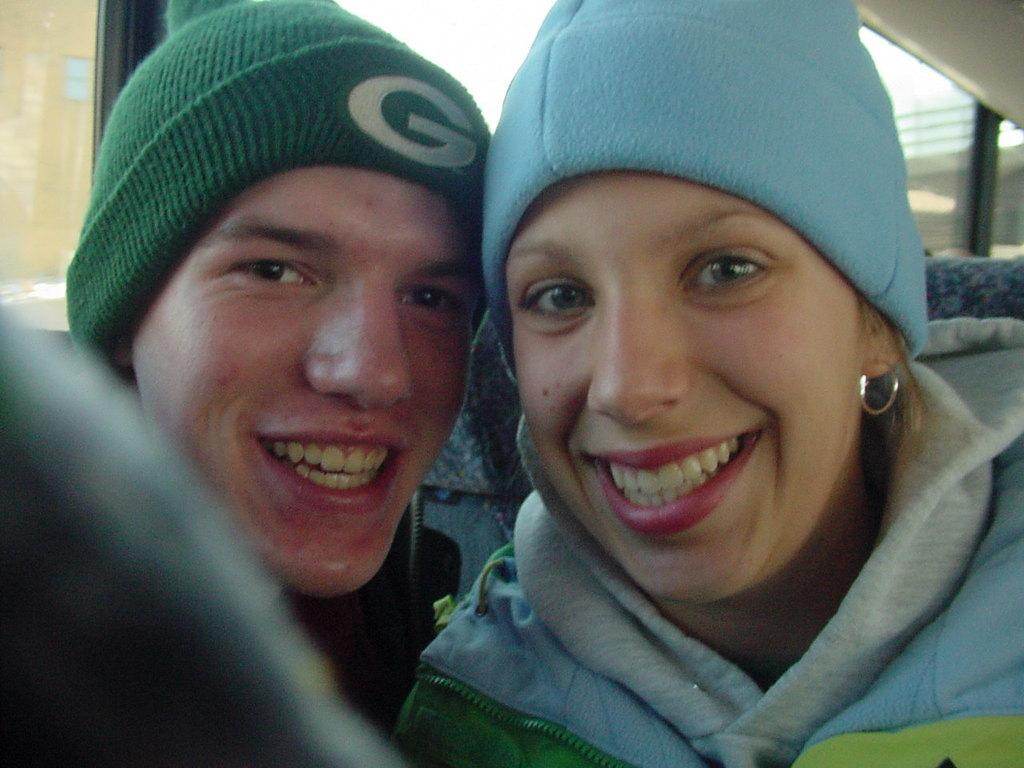How many people are in the image? There are two persons in the image. What are the two persons doing in the image? The two persons are sitting in a vehicle. What is the facial expression of the two persons? The two persons are smiling. What type of bells can be heard in the image? There are no bells present or audible in the image. 